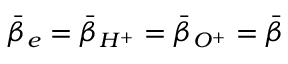<formula> <loc_0><loc_0><loc_500><loc_500>\bar { \beta } _ { e } = \bar { \beta } _ { H ^ { + } } = \bar { \beta } _ { O ^ { + } } = \bar { \beta }</formula> 